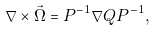Convert formula to latex. <formula><loc_0><loc_0><loc_500><loc_500>\nabla \times \vec { \Omega } = P ^ { - 1 } \nabla Q P ^ { - 1 } ,</formula> 